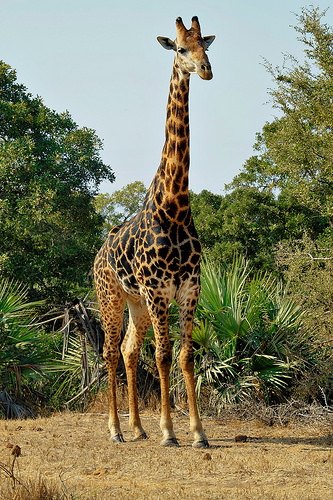<image>
Can you confirm if the tree is to the left of the giraffe? Yes. From this viewpoint, the tree is positioned to the left side relative to the giraffe. Is the tree in front of the giraffe? No. The tree is not in front of the giraffe. The spatial positioning shows a different relationship between these objects. 